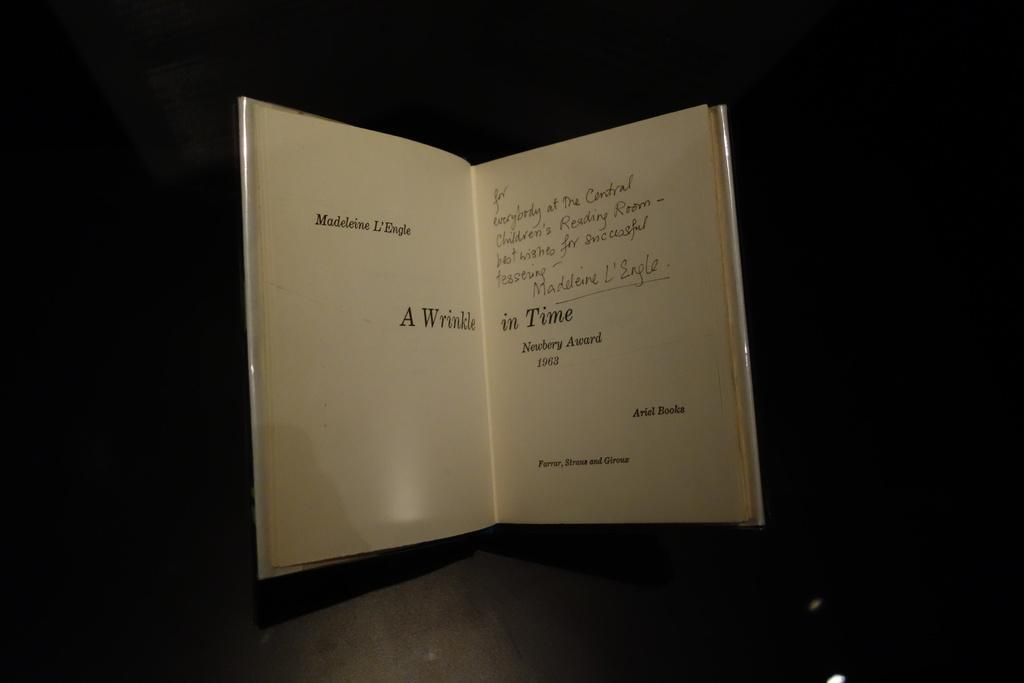<image>
Provide a brief description of the given image. A signed book to the people at the Central Children's Reading Room. 